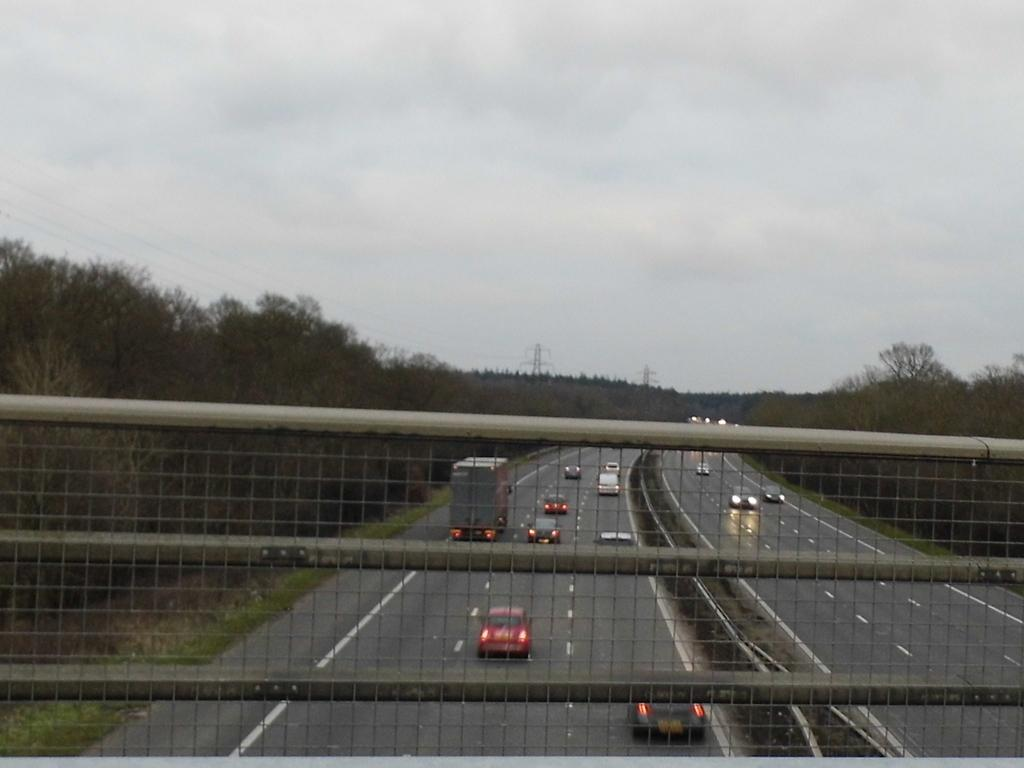What type of barrier can be seen in the image? There is a fence in the image. What can be seen in the distance behind the fence? There are vehicles on roads, trees, towers, wires, and the sky visible in the background of the image. What type of metal is the fence made of in the image? The facts provided do not mention the material of the fence, so it cannot be determined from the image. 